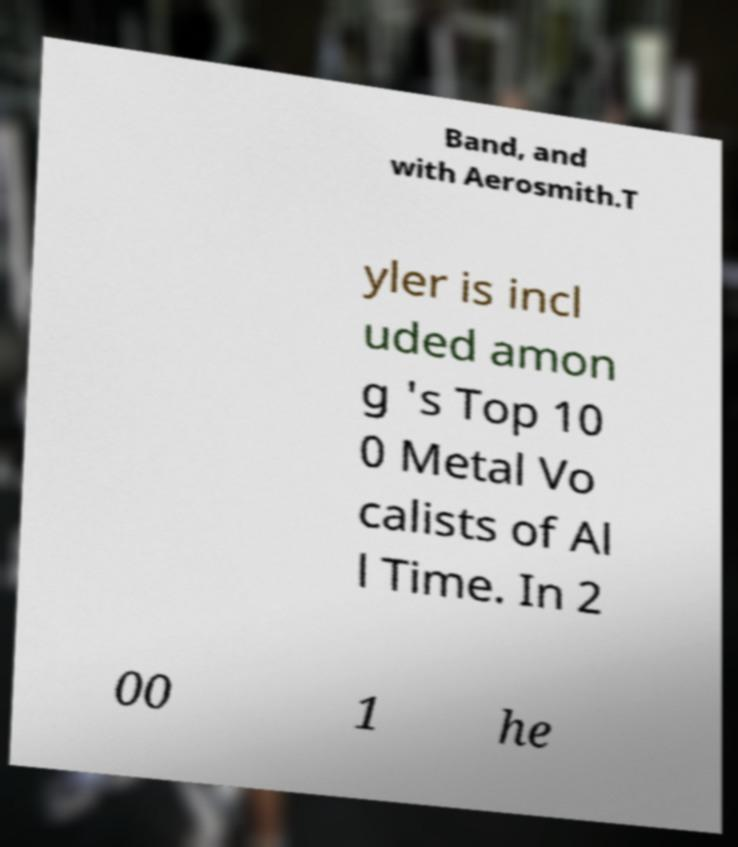Could you assist in decoding the text presented in this image and type it out clearly? Band, and with Aerosmith.T yler is incl uded amon g 's Top 10 0 Metal Vo calists of Al l Time. In 2 00 1 he 